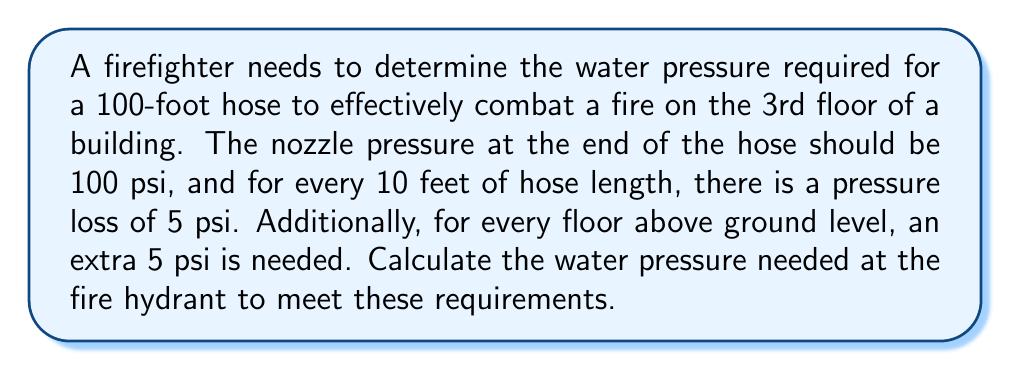Can you solve this math problem? Let's approach this problem step-by-step:

1. Calculate the pressure loss due to hose length:
   * Pressure loss per 10 feet = 5 psi
   * Total hose length = 100 feet
   * Number of 10-foot sections = $\frac{100}{10} = 10$
   * Total pressure loss due to hose length = $10 \times 5 = 50$ psi

2. Calculate the additional pressure needed for elevation:
   * Pressure needed per floor above ground = 5 psi
   * Fire is on the 3rd floor, so 2 floors above ground
   * Additional pressure for elevation = $2 \times 5 = 10$ psi

3. Sum up the pressure requirements:
   * Nozzle pressure required = 100 psi
   * Pressure loss due to hose length = 50 psi
   * Additional pressure for elevation = 10 psi
   * Total pressure needed = $100 + 50 + 10 = 160$ psi

Therefore, the water pressure needed at the fire hydrant is 160 psi.
Answer: 160 psi 